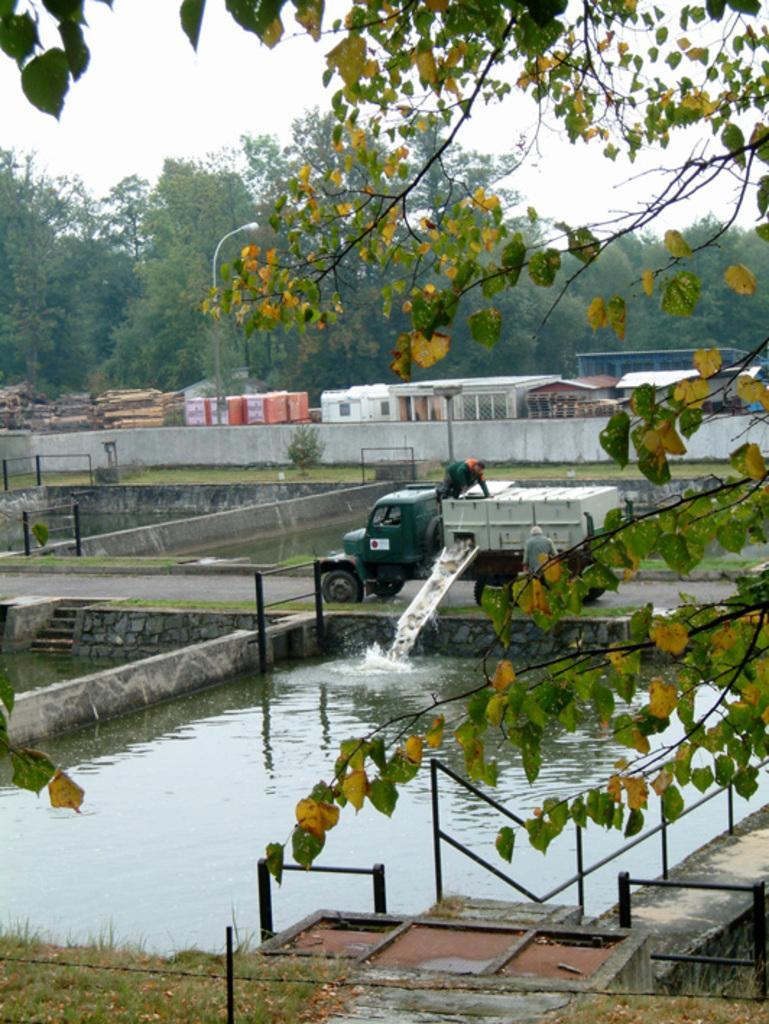How would you summarize this image in a sentence or two? In this image we can see water. There is a vehicle and two persons. In the back there are walls. Also there are steps. And we can see branches of trees. In the background there are trees. Also there is sky. And there are buildings. 